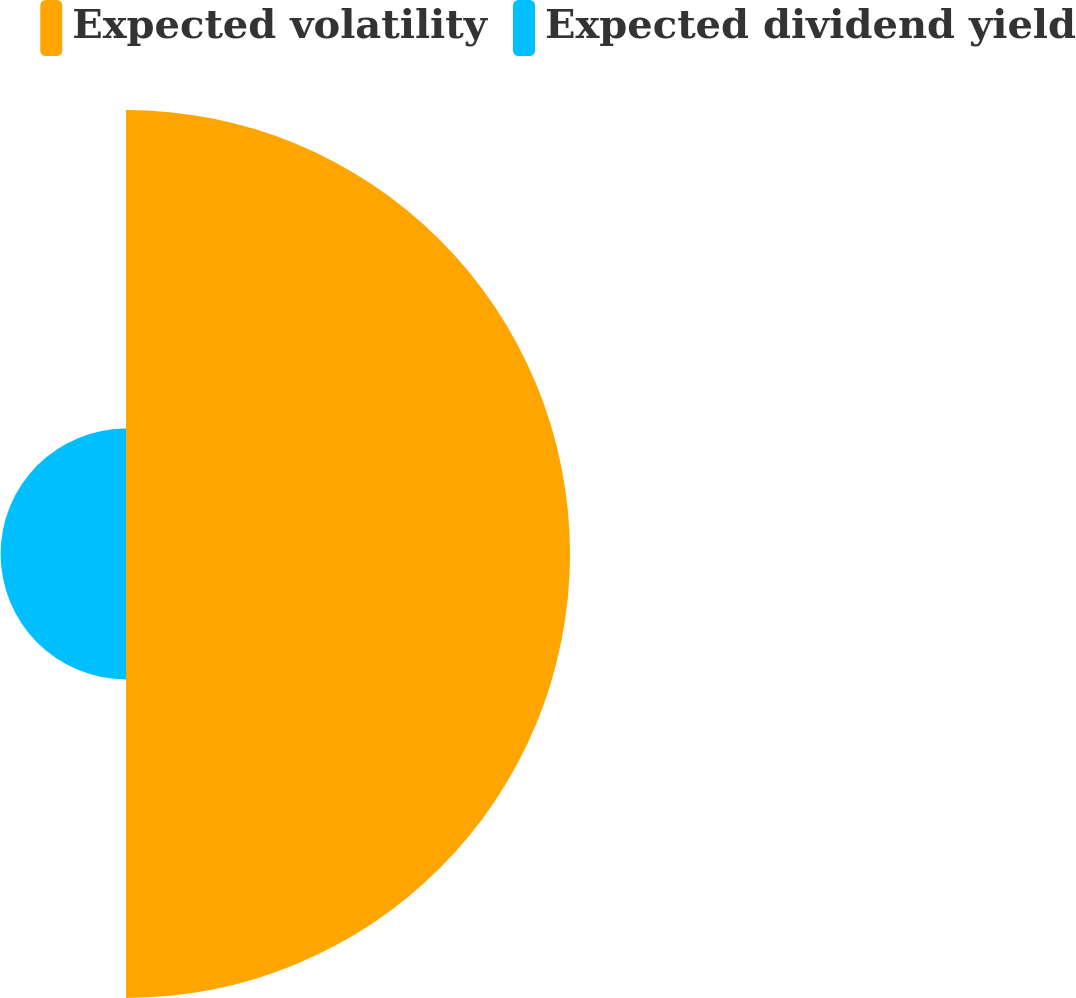<chart> <loc_0><loc_0><loc_500><loc_500><pie_chart><fcel>Expected volatility<fcel>Expected dividend yield<nl><fcel>77.98%<fcel>22.02%<nl></chart> 